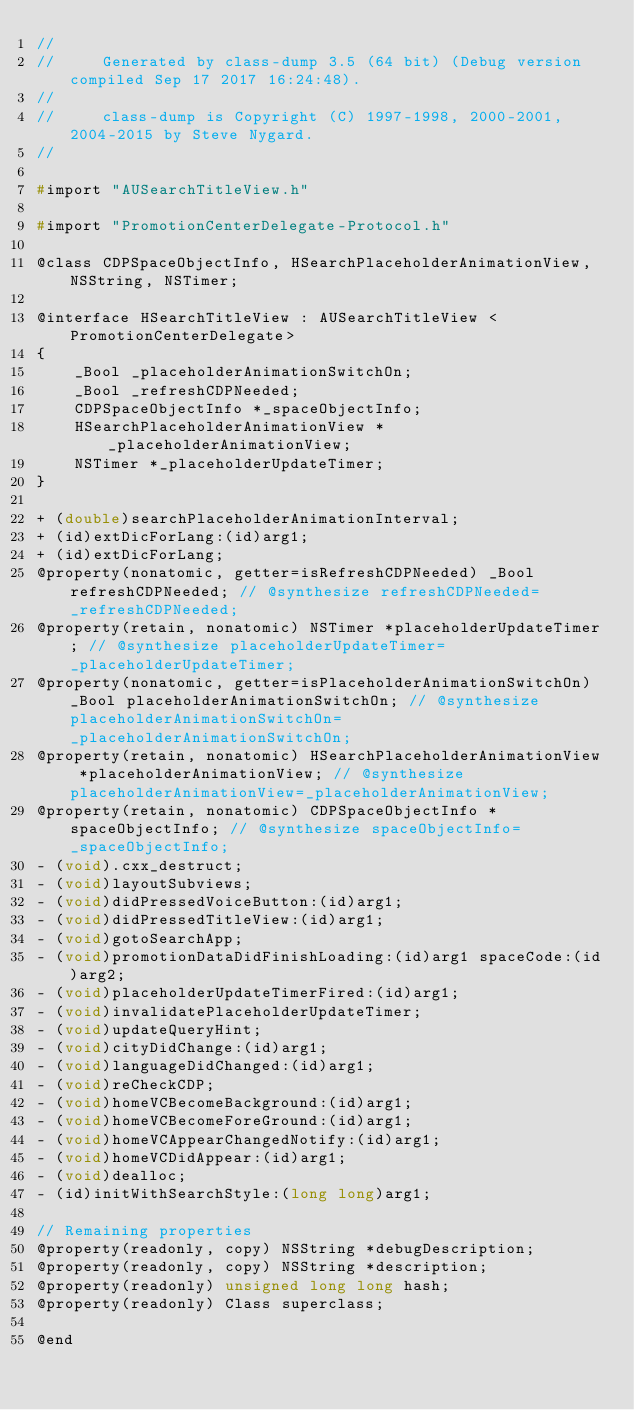Convert code to text. <code><loc_0><loc_0><loc_500><loc_500><_C_>//
//     Generated by class-dump 3.5 (64 bit) (Debug version compiled Sep 17 2017 16:24:48).
//
//     class-dump is Copyright (C) 1997-1998, 2000-2001, 2004-2015 by Steve Nygard.
//

#import "AUSearchTitleView.h"

#import "PromotionCenterDelegate-Protocol.h"

@class CDPSpaceObjectInfo, HSearchPlaceholderAnimationView, NSString, NSTimer;

@interface HSearchTitleView : AUSearchTitleView <PromotionCenterDelegate>
{
    _Bool _placeholderAnimationSwitchOn;
    _Bool _refreshCDPNeeded;
    CDPSpaceObjectInfo *_spaceObjectInfo;
    HSearchPlaceholderAnimationView *_placeholderAnimationView;
    NSTimer *_placeholderUpdateTimer;
}

+ (double)searchPlaceholderAnimationInterval;
+ (id)extDicForLang:(id)arg1;
+ (id)extDicForLang;
@property(nonatomic, getter=isRefreshCDPNeeded) _Bool refreshCDPNeeded; // @synthesize refreshCDPNeeded=_refreshCDPNeeded;
@property(retain, nonatomic) NSTimer *placeholderUpdateTimer; // @synthesize placeholderUpdateTimer=_placeholderUpdateTimer;
@property(nonatomic, getter=isPlaceholderAnimationSwitchOn) _Bool placeholderAnimationSwitchOn; // @synthesize placeholderAnimationSwitchOn=_placeholderAnimationSwitchOn;
@property(retain, nonatomic) HSearchPlaceholderAnimationView *placeholderAnimationView; // @synthesize placeholderAnimationView=_placeholderAnimationView;
@property(retain, nonatomic) CDPSpaceObjectInfo *spaceObjectInfo; // @synthesize spaceObjectInfo=_spaceObjectInfo;
- (void).cxx_destruct;
- (void)layoutSubviews;
- (void)didPressedVoiceButton:(id)arg1;
- (void)didPressedTitleView:(id)arg1;
- (void)gotoSearchApp;
- (void)promotionDataDidFinishLoading:(id)arg1 spaceCode:(id)arg2;
- (void)placeholderUpdateTimerFired:(id)arg1;
- (void)invalidatePlaceholderUpdateTimer;
- (void)updateQueryHint;
- (void)cityDidChange:(id)arg1;
- (void)languageDidChanged:(id)arg1;
- (void)reCheckCDP;
- (void)homeVCBecomeBackground:(id)arg1;
- (void)homeVCBecomeForeGround:(id)arg1;
- (void)homeVCAppearChangedNotify:(id)arg1;
- (void)homeVCDidAppear:(id)arg1;
- (void)dealloc;
- (id)initWithSearchStyle:(long long)arg1;

// Remaining properties
@property(readonly, copy) NSString *debugDescription;
@property(readonly, copy) NSString *description;
@property(readonly) unsigned long long hash;
@property(readonly) Class superclass;

@end

</code> 